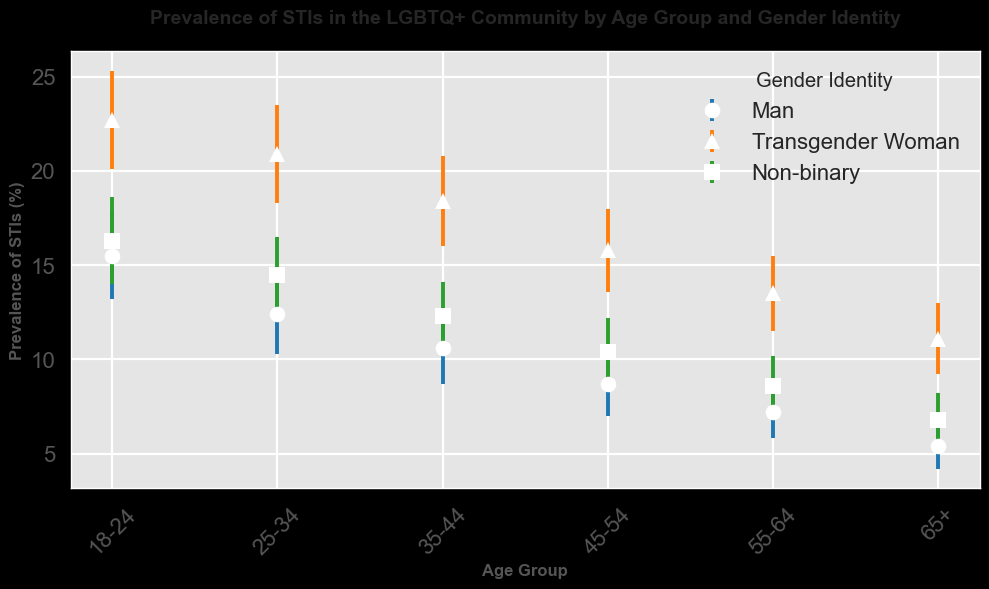How does STI prevalence compare between Man and Transgender Woman in the 18-24 age group? To answer this, look at the STI prevalence percentages for both groups in the 18-24 age range. STI prevalence is 15.5% for Man and 22.7% for Transgender Woman. Comparing these values, Transgender Women have a higher prevalence.
Answer: Transgender Women have higher prevalence Which gender identity has the lowest STI prevalence for the 65+ age group? Examine the data points for the 65+ age group. Man has 5.4%, Transgender Woman has 11.1%, and Non-binary has 6.8%. The lowest prevalence is for Man.
Answer: Man Which age group shows the highest STI prevalence for Non-binary individuals? Review the STI prevalence percentages for Non-binary individuals within each age group. The highest prevalence (16.3%) is in the 18-24 age group.
Answer: 18-24 Are the confidence intervals for Non-binary individuals in the 35-44 and 55-64 age groups overlapping? Check the lower and upper confidence intervals for Non-binary individuals in these age groups. For 35-44, the interval is 10.5% to 14.1%. For 55-64, the interval is 7.0% to 10.2%. Since these ranges do not overlap, the intervals are not overlapping.
Answer: No How much higher is the STI prevalence for Transgender Women compared to Men in the 25-34 age group? Subtract the STI prevalence for Men from that for Transgender Women in the 25-34 age group. Transgender Women have 20.9%, and Men have 12.4%. 20.9% - 12.4% = 8.5%.
Answer: 8.5% What is the average STI prevalence across all age groups for Men? Sum the prevalence percentages for Men across all age groups and divide by the number of age groups. (15.5% + 12.4% + 10.6% + 8.7% + 7.2% + 5.4%) / 6 = 10%.
Answer: 10% Which gender identity has the smallest error bars in the 45-54 age group? Determine the range of error bars for each gender identity in this age group. The differences are 8.7% - 7.0% = 1.7% (Man), 18.0% - 15.8% = 2.2% (Transgender Woman), and 12.2% - 10.4% = 1.8% (Non-binary). The smallest error bar range is for Man.
Answer: Man What is the difference in STI prevalence between the 55-64 and 65+ age groups for Transgender Women? Subtract the prevalence for the 65+ age group from the 55-64 age group for Transgender Women. 13.5% - 11.1% = 2.4%.
Answer: 2.4% Which age group shows the largest drop in STI prevalence for Non-binary individuals compared to the previous age group? Calculate the differences between consecutive age groups for Non-binary individuals. Largest drop is between 55-64 and 18-24, which is 16.3% - 8.6% = 7.7%
Answer: 55-64 to 18-24 How does the STI prevalence for Transgender Women in the 45-54 age group compare to Non-binary individuals in the same age group? Examine the prevalence percentages for both groups in the 45-54 age range. The Transgender Woman is 15.8%, and Non-binary is 10.4%. Transgender Women have a higher prevalence.
Answer: Transgender Women have higher prevalence 